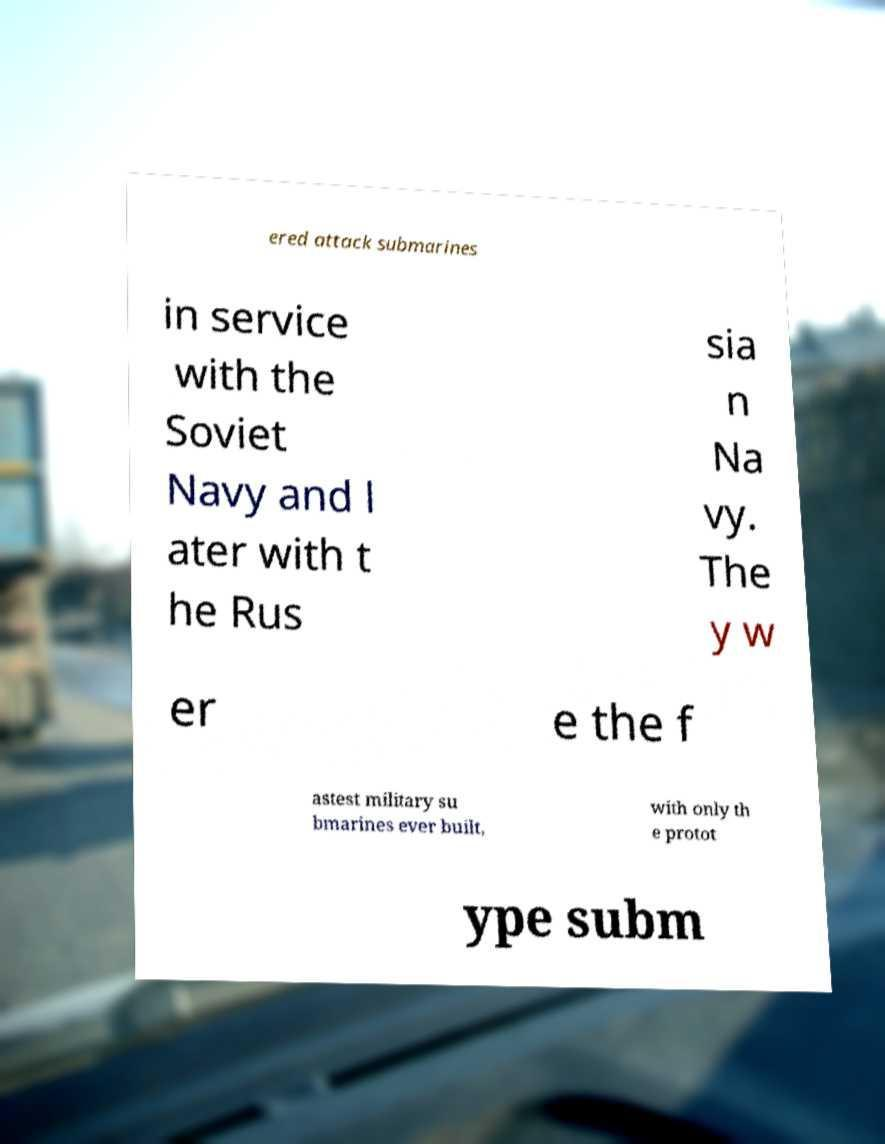Can you read and provide the text displayed in the image?This photo seems to have some interesting text. Can you extract and type it out for me? ered attack submarines in service with the Soviet Navy and l ater with t he Rus sia n Na vy. The y w er e the f astest military su bmarines ever built, with only th e protot ype subm 